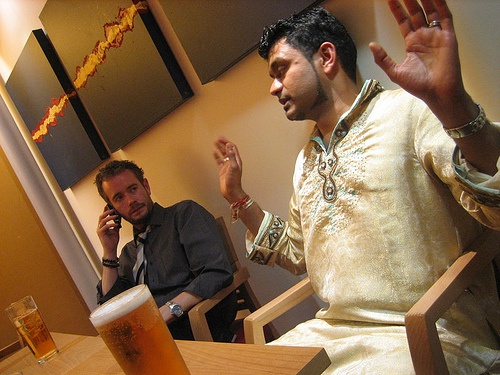Describe the objects in this image and their specific colors. I can see people in white, ivory, black, maroon, and tan tones, people in white, black, maroon, gray, and brown tones, dining table in white, brown, maroon, and tan tones, chair in white, maroon, black, and tan tones, and cup in white, maroon, brown, and tan tones in this image. 